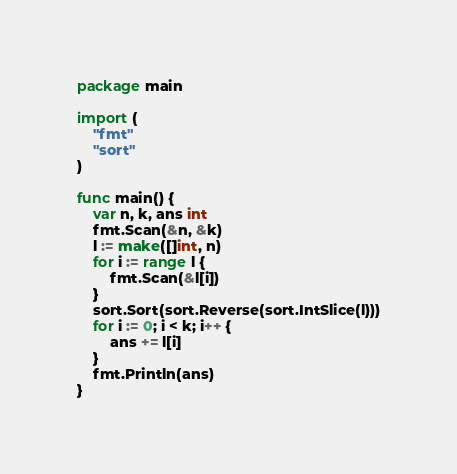<code> <loc_0><loc_0><loc_500><loc_500><_Go_>package main

import (
	"fmt"
	"sort"
)

func main() {
	var n, k, ans int
	fmt.Scan(&n, &k)
	l := make([]int, n)
	for i := range l {
		fmt.Scan(&l[i])
	}
	sort.Sort(sort.Reverse(sort.IntSlice(l)))
	for i := 0; i < k; i++ {
		ans += l[i]
	}
	fmt.Println(ans)
}
</code> 